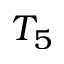Convert formula to latex. <formula><loc_0><loc_0><loc_500><loc_500>T _ { 5 }</formula> 